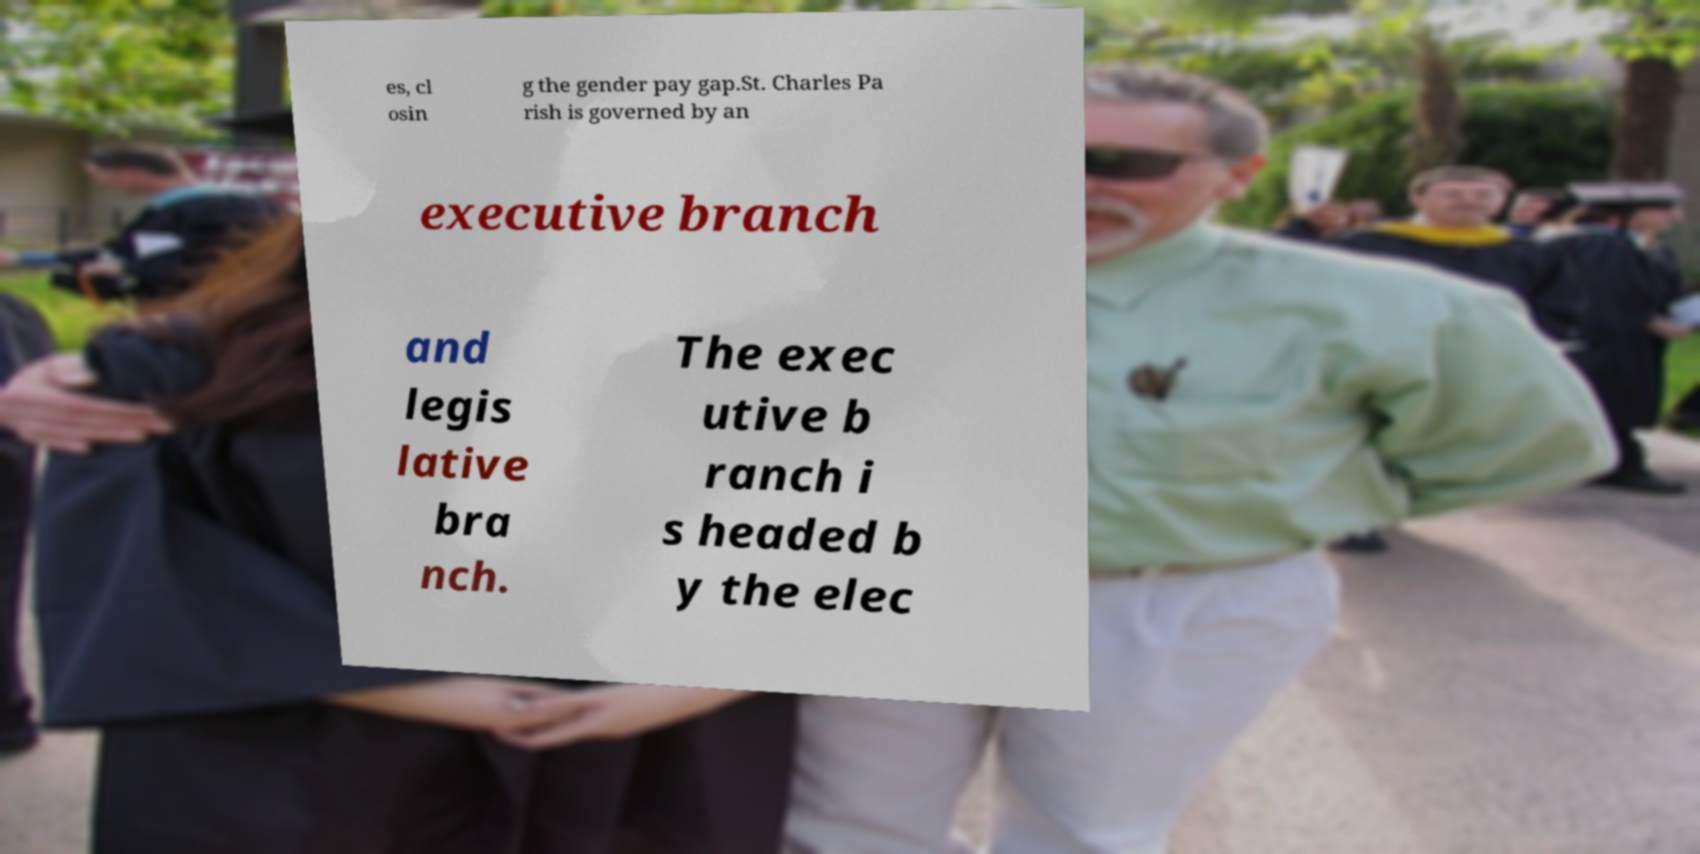There's text embedded in this image that I need extracted. Can you transcribe it verbatim? es, cl osin g the gender pay gap.St. Charles Pa rish is governed by an executive branch and legis lative bra nch. The exec utive b ranch i s headed b y the elec 